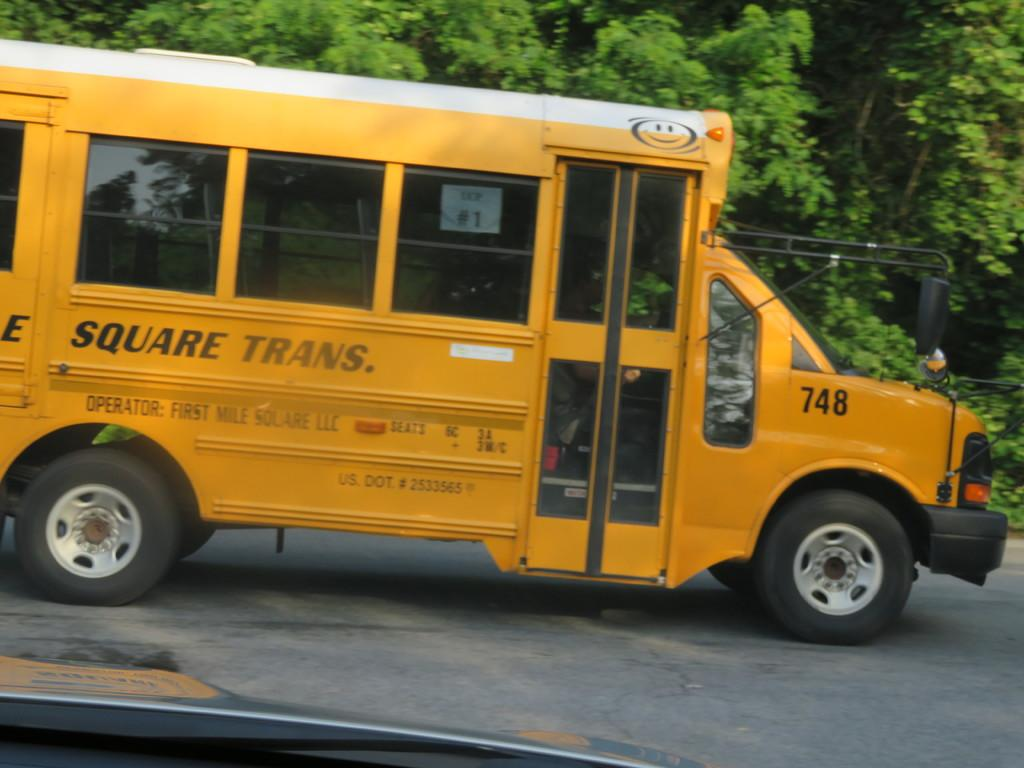What color is the vehicle in the image? The vehicle in the image is yellow. Where is the vehicle located in the image? The vehicle is placed on the ground. What can be seen in the background of the image? There is a group of trees in the background of the image. What type of substance is being used to clean the alley in the image? There is no alley or substance present in the image; it features a yellow vehicle on the ground with a group of trees in the background. 